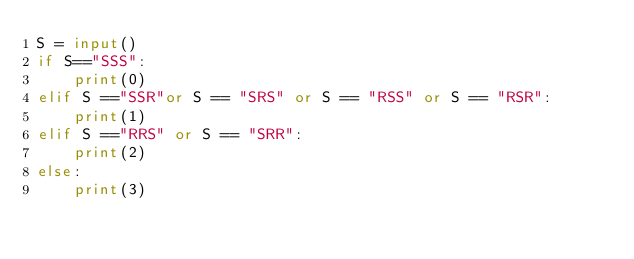<code> <loc_0><loc_0><loc_500><loc_500><_Python_>S = input()
if S=="SSS":
    print(0)
elif S =="SSR"or S == "SRS" or S == "RSS" or S == "RSR":
    print(1)
elif S =="RRS" or S == "SRR":
    print(2)
else:
    print(3)

</code> 